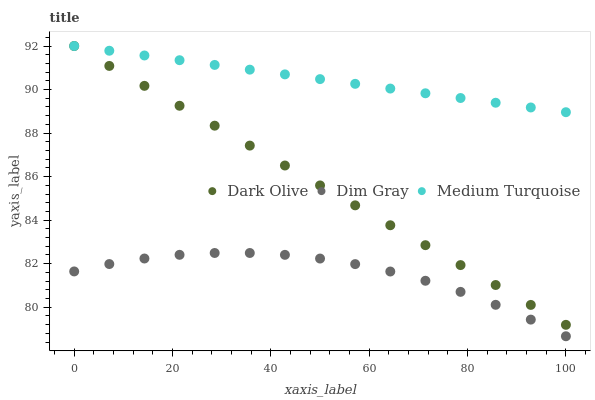Does Dim Gray have the minimum area under the curve?
Answer yes or no. Yes. Does Medium Turquoise have the maximum area under the curve?
Answer yes or no. Yes. Does Dark Olive have the minimum area under the curve?
Answer yes or no. No. Does Dark Olive have the maximum area under the curve?
Answer yes or no. No. Is Medium Turquoise the smoothest?
Answer yes or no. Yes. Is Dim Gray the roughest?
Answer yes or no. Yes. Is Dark Olive the smoothest?
Answer yes or no. No. Is Dark Olive the roughest?
Answer yes or no. No. Does Dim Gray have the lowest value?
Answer yes or no. Yes. Does Dark Olive have the lowest value?
Answer yes or no. No. Does Medium Turquoise have the highest value?
Answer yes or no. Yes. Is Dim Gray less than Dark Olive?
Answer yes or no. Yes. Is Dark Olive greater than Dim Gray?
Answer yes or no. Yes. Does Dark Olive intersect Medium Turquoise?
Answer yes or no. Yes. Is Dark Olive less than Medium Turquoise?
Answer yes or no. No. Is Dark Olive greater than Medium Turquoise?
Answer yes or no. No. Does Dim Gray intersect Dark Olive?
Answer yes or no. No. 